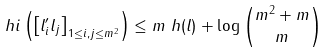<formula> <loc_0><loc_0><loc_500><loc_500>\ h i \left ( \left [ l ^ { \prime } _ { i } l _ { j } \right ] _ { 1 \leq i , j \leq m ^ { 2 } } \right ) & \leq m \ h ( l ) + \log \binom { m ^ { 2 } + m } { m }</formula> 